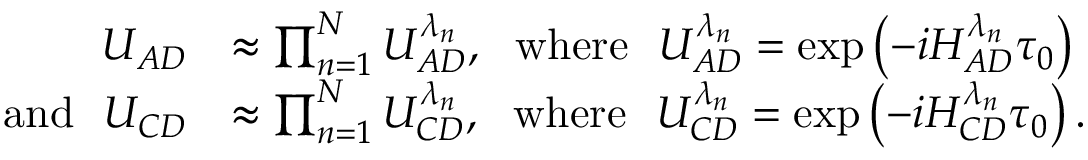Convert formula to latex. <formula><loc_0><loc_0><loc_500><loc_500>\begin{array} { r l } { U _ { A D } } & { \approx \prod _ { n = 1 } ^ { N } U _ { A D } ^ { \lambda _ { n } } , w h e r e U _ { A D } ^ { \lambda _ { n } } = \exp \left ( - i H _ { A D } ^ { \lambda _ { n } } \tau _ { 0 } \right ) } \\ { a n d U _ { C D } } & { \approx \prod _ { n = 1 } ^ { N } U _ { C D } ^ { \lambda _ { n } } , w h e r e U _ { C D } ^ { \lambda _ { n } } = \exp \left ( - i H _ { C D } ^ { \lambda _ { n } } \tau _ { 0 } \right ) . } \end{array}</formula> 